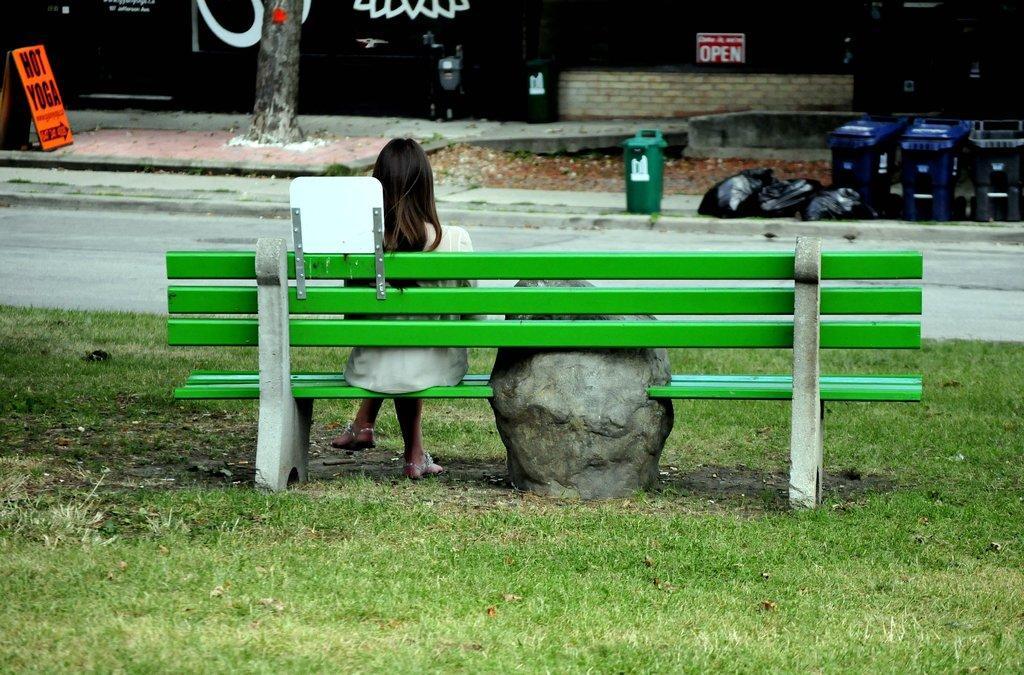Can you describe this image briefly? In this image, we can see a person wearing clothes and sitting on the bench. There are trash bins in the top right of the image. There is a wall and stem at the top of the image. There is a board in the top left of the image. There is a road in the middle of the image. 